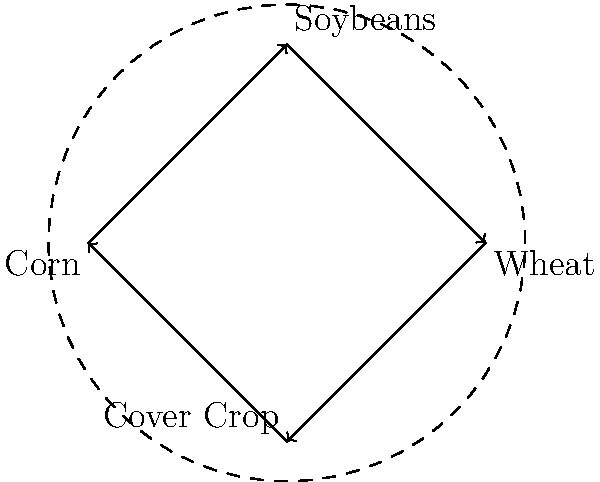As an agritourism business owner, you're implementing a 4-year crop rotation system to maximize soil health and yield. The cyclic graph represents the rotation order: Corn → Soybeans → Wheat → Cover Crop → Corn. If you have 400 acres of farmland and want to maintain consistent production each year, how many acres should be allocated to each crop annually? To solve this problem, we need to follow these steps:

1. Understand the cycle:
   The graph shows a 4-year rotation cycle: Corn → Soybeans → Wheat → Cover Crop → Corn

2. Recognize the equal distribution requirement:
   To maintain consistent production each year, we need to allocate an equal amount of land to each stage of the rotation.

3. Calculate the allocation:
   - Total farmland: 400 acres
   - Number of stages in the rotation: 4
   - Acres per stage = Total farmland ÷ Number of stages
   - Acres per stage = 400 ÷ 4 = 100 acres

4. Interpret the result:
   Each year, 100 acres should be allocated to each crop in the rotation:
   - 100 acres of Corn
   - 100 acres of Soybeans
   - 100 acres of Wheat
   - 100 acres of Cover Crop

This allocation ensures that:
a) The total land use remains constant at 400 acres.
b) Each crop is grown on the same amount of land every year.
c) The full rotation cycle is maintained across the entire farm.
Answer: 100 acres per crop 